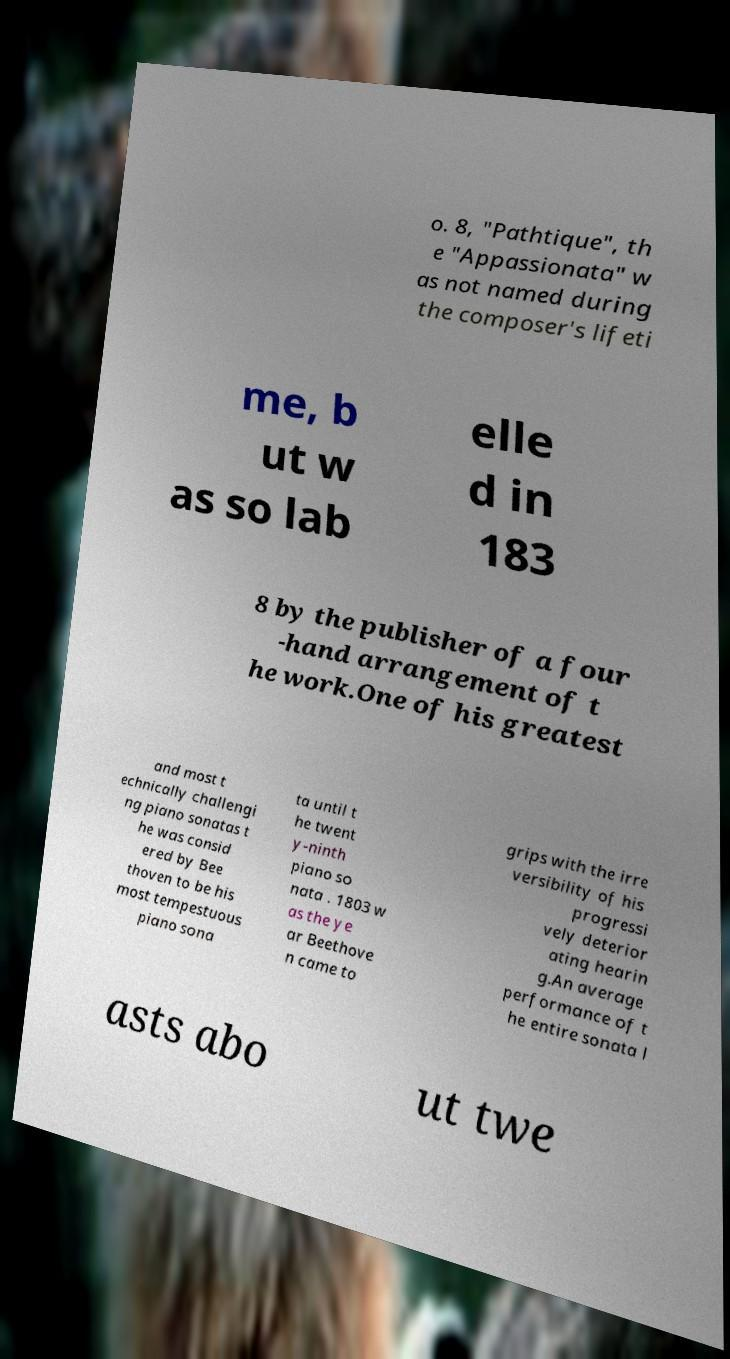For documentation purposes, I need the text within this image transcribed. Could you provide that? o. 8, "Pathtique", th e "Appassionata" w as not named during the composer's lifeti me, b ut w as so lab elle d in 183 8 by the publisher of a four -hand arrangement of t he work.One of his greatest and most t echnically challengi ng piano sonatas t he was consid ered by Bee thoven to be his most tempestuous piano sona ta until t he twent y-ninth piano so nata . 1803 w as the ye ar Beethove n came to grips with the irre versibility of his progressi vely deterior ating hearin g.An average performance of t he entire sonata l asts abo ut twe 